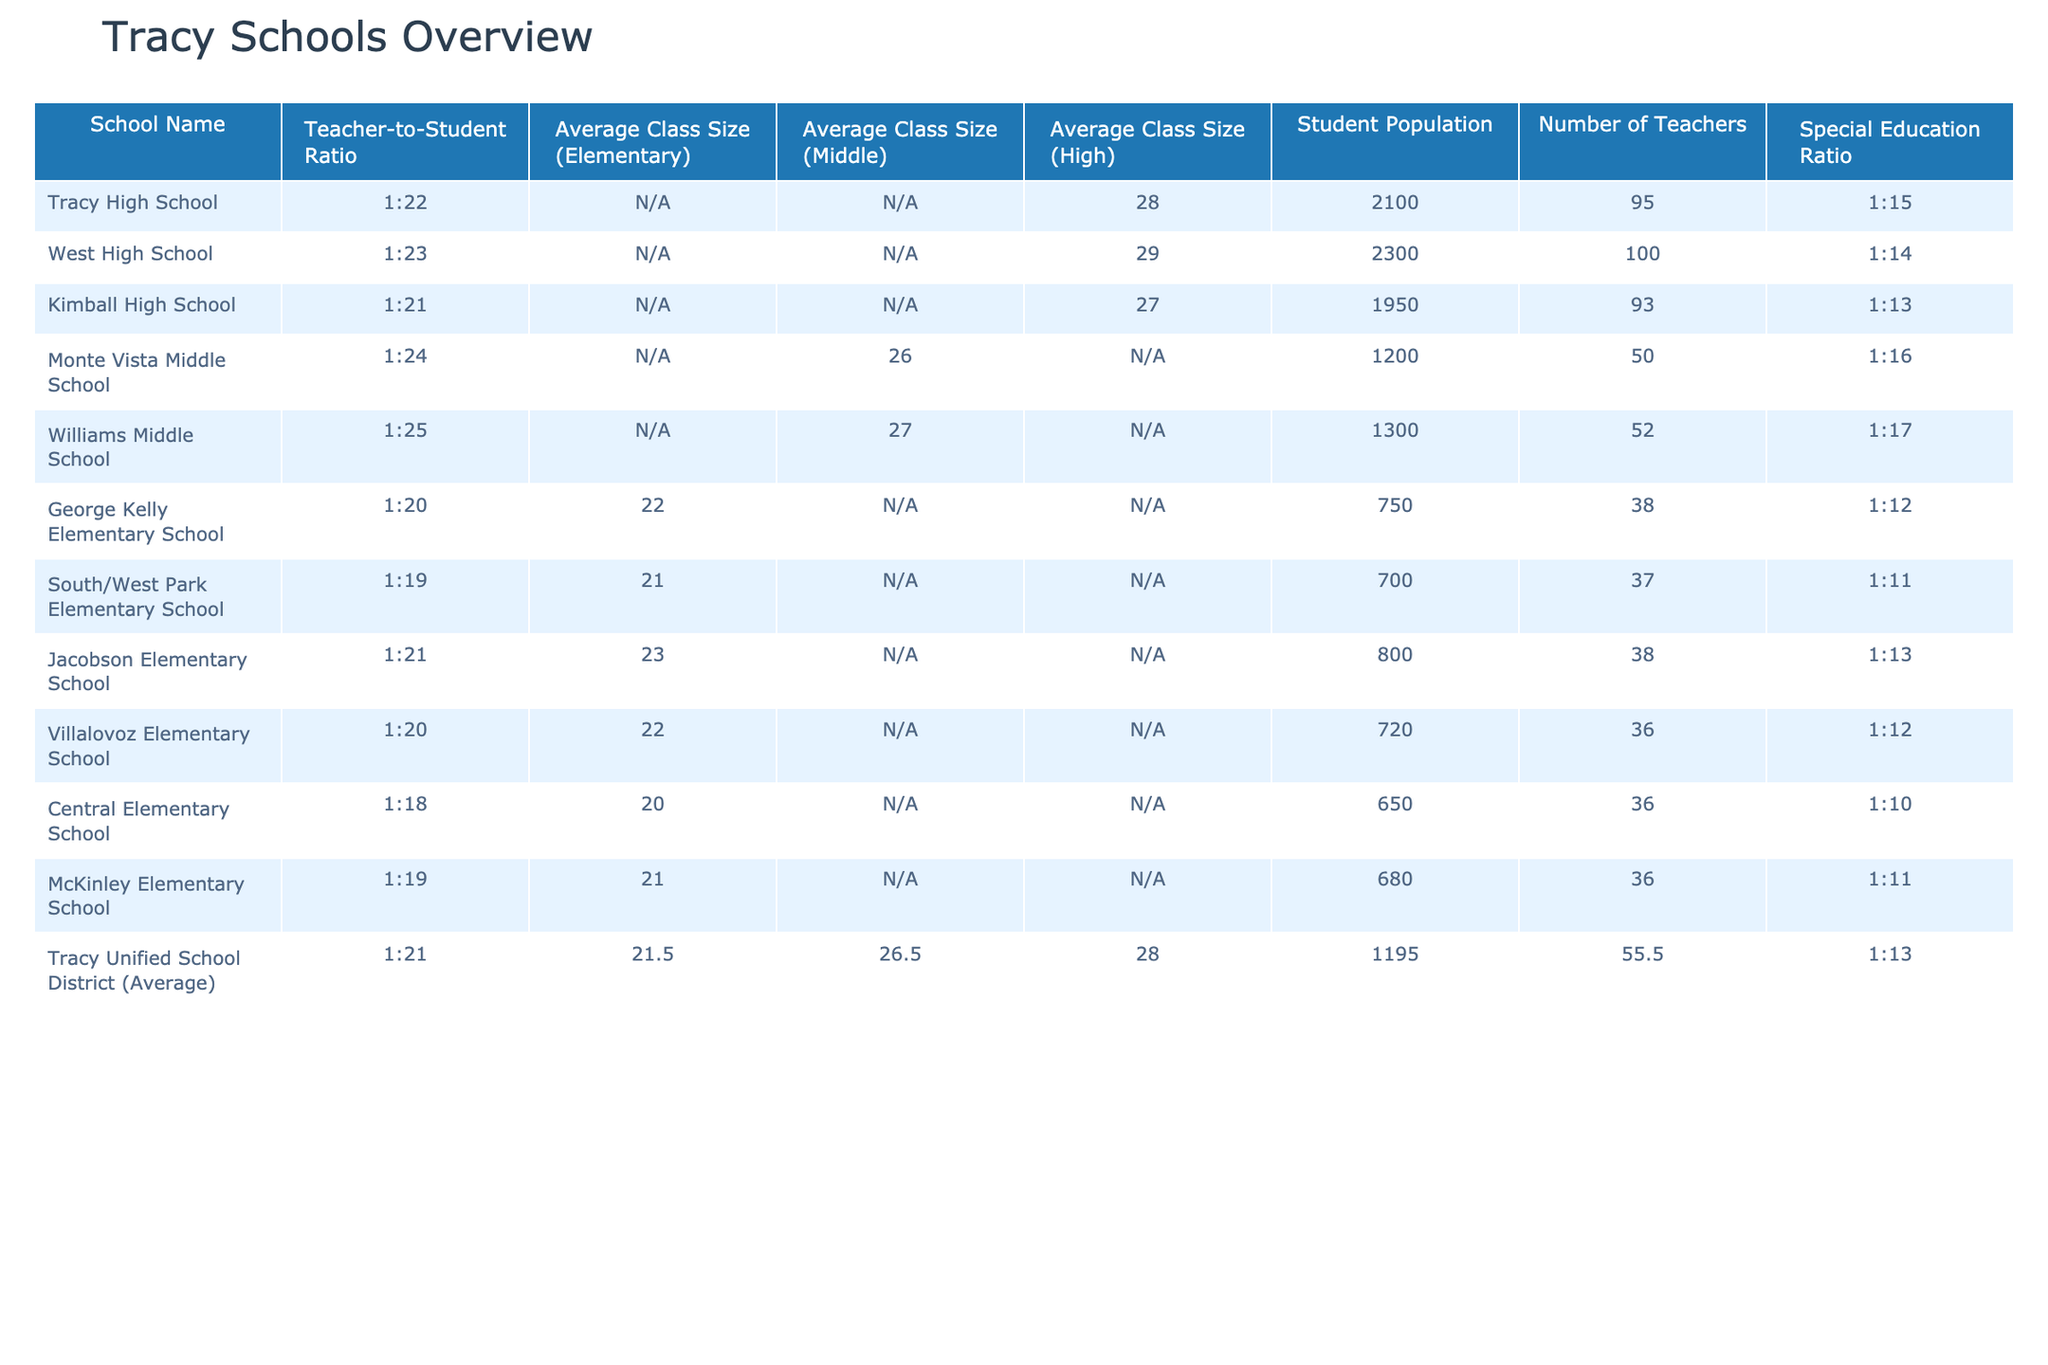What is the teacher-to-student ratio at Tracy High School? The table lists the teacher-to-student ratio for Tracy High School as 1:22.
Answer: 1:22 Which elementary school has the smallest average class size? Comparing the average class sizes for elementary schools: George Kelly (22), South/West Park (21), Jacobson (23), Villalovoz (22), Central (20), and McKinley (21). Central Elementary has the smallest average class size at 20.
Answer: Central Elementary School What is the average class size for middle schools in Tracy? The average class sizes for Monte Vista Middle (26) and Williams Middle (27) are compared. The average is (26 + 27) / 2 = 26.5.
Answer: 26.5 How many teachers are there at Kimball High School? The table shows that Kimball High School has a total of 93 teachers listed.
Answer: 93 Is the special education ratio for West High School better than for Monte Vista Middle School? West High School has a special education ratio of 1:14, while Monte Vista Middle School has a ratio of 1:16. Since 1:14 indicates more resources per student, it is indeed better.
Answer: Yes What is the total student population in elementary schools? The student populations for each elementary school are George Kelly (750), South/West Park (700), Jacobson (800), Villalovoz (720), Central (650), and McKinley (680). Summing these gives 750 + 700 + 800 + 720 + 650 + 680 = 3900.
Answer: 3900 Which school has the highest student population, and what is that number? Comparing student populations: Tracy High (2100), West High (2300), Kimball High (1950), Monte Vista Middle (1200), Williams Middle (1300), and all elementary schools. West High School has the highest population at 2300.
Answer: West High School, 2300 What is the average teacher-to-student ratio for all Tracy schools? The ratios for all schools are: 1:22, 1:23, 1:21, 1:24, 1:25, 1:20, 1:19, 1:21, 1:20, 1:18, 1:19. Converting these ratios to numerical values gives average ratio as 1/(22, 23, 21, 24, 25, 20, 19, 21, 20, 18, 19) = approximately 1:21.
Answer: 1:21 How many more teachers are at South/West Park Elementary compared to Central Elementary? South/West Park has 37 teachers, while Central Elementary has 36. The difference is 37 - 36 = 1.
Answer: 1 Which middle school has a higher teacher-to-student ratio, and what is that ratio? Comparatively, Monte Vista Middle (1:24) and Williams Middle (1:25) show that Monte Vista has a better ratio, with a lower number.
Answer: Monte Vista Middle School, 1:24 